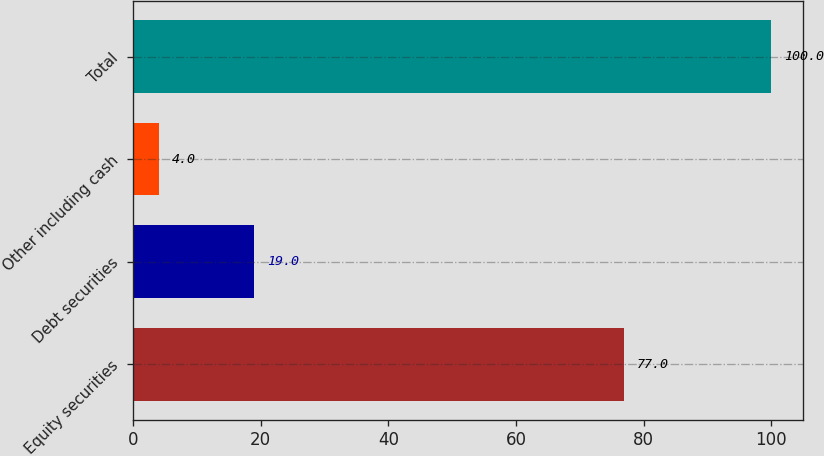<chart> <loc_0><loc_0><loc_500><loc_500><bar_chart><fcel>Equity securities<fcel>Debt securities<fcel>Other including cash<fcel>Total<nl><fcel>77<fcel>19<fcel>4<fcel>100<nl></chart> 